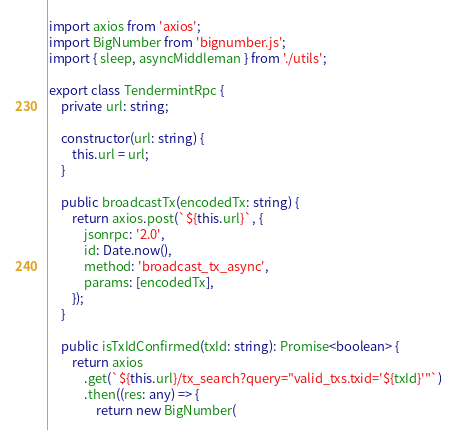<code> <loc_0><loc_0><loc_500><loc_500><_TypeScript_>import axios from 'axios';
import BigNumber from 'bignumber.js';
import { sleep, asyncMiddleman } from './utils';

export class TendermintRpc {
    private url: string;

    constructor(url: string) {
        this.url = url;
    }

    public broadcastTx(encodedTx: string) {
        return axios.post(`${this.url}`, {
            jsonrpc: '2.0',
            id: Date.now(),
            method: 'broadcast_tx_async',
            params: [encodedTx],
        });
    }

    public isTxIdConfirmed(txId: string): Promise<boolean> {
        return axios
            .get(`${this.url}/tx_search?query="valid_txs.txid='${txId}'"`)
            .then((res: any) => {
                return new BigNumber(</code> 